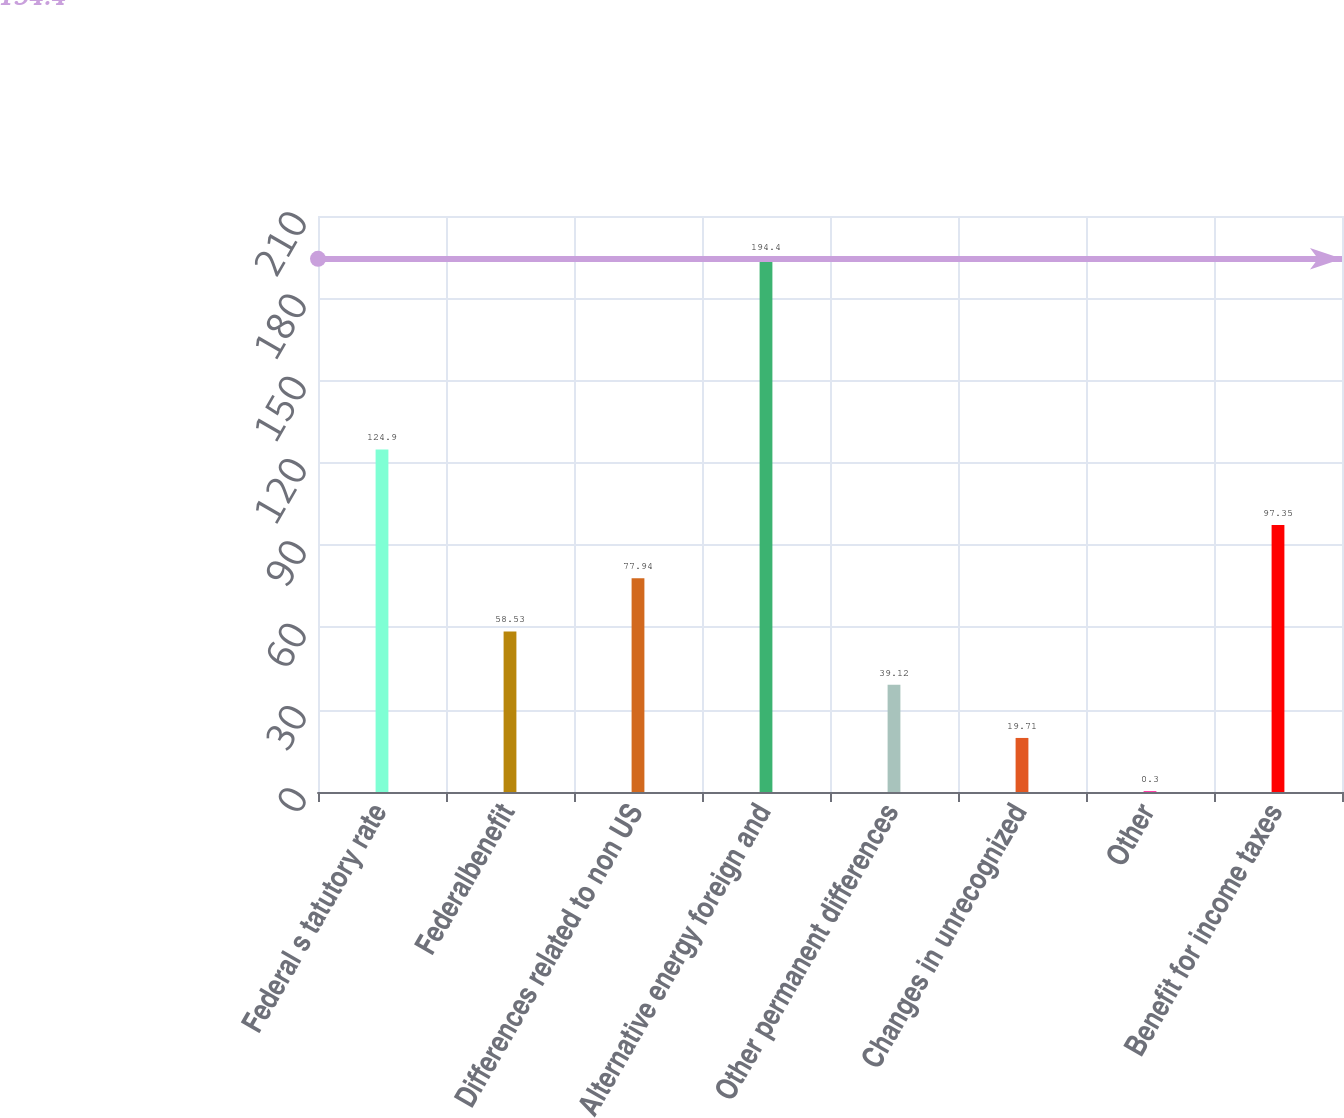Convert chart to OTSL. <chart><loc_0><loc_0><loc_500><loc_500><bar_chart><fcel>Federal s tatutory rate<fcel>Federalbenefit<fcel>Differences related to non US<fcel>Alternative energy foreign and<fcel>Other permanent differences<fcel>Changes in unrecognized<fcel>Other<fcel>Benefit for income taxes<nl><fcel>124.9<fcel>58.53<fcel>77.94<fcel>194.4<fcel>39.12<fcel>19.71<fcel>0.3<fcel>97.35<nl></chart> 